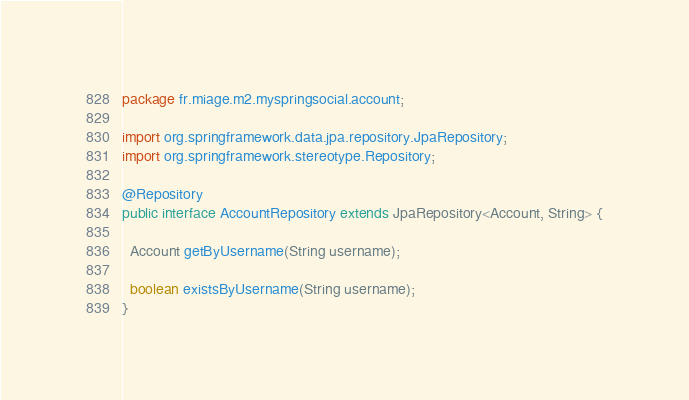Convert code to text. <code><loc_0><loc_0><loc_500><loc_500><_Java_>package fr.miage.m2.myspringsocial.account;

import org.springframework.data.jpa.repository.JpaRepository;
import org.springframework.stereotype.Repository;

@Repository
public interface AccountRepository extends JpaRepository<Account, String> {

  Account getByUsername(String username);

  boolean existsByUsername(String username);
}
</code> 